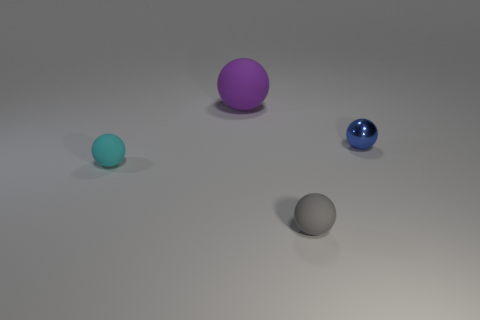Subtract all small balls. How many balls are left? 1 Add 2 large purple balls. How many objects exist? 6 Add 3 small balls. How many small balls exist? 6 Subtract all gray spheres. How many spheres are left? 3 Subtract 1 gray spheres. How many objects are left? 3 Subtract all cyan spheres. Subtract all cyan cylinders. How many spheres are left? 3 Subtract all yellow cylinders. How many cyan balls are left? 1 Subtract all gray matte balls. Subtract all tiny rubber balls. How many objects are left? 1 Add 3 tiny cyan rubber spheres. How many tiny cyan rubber spheres are left? 4 